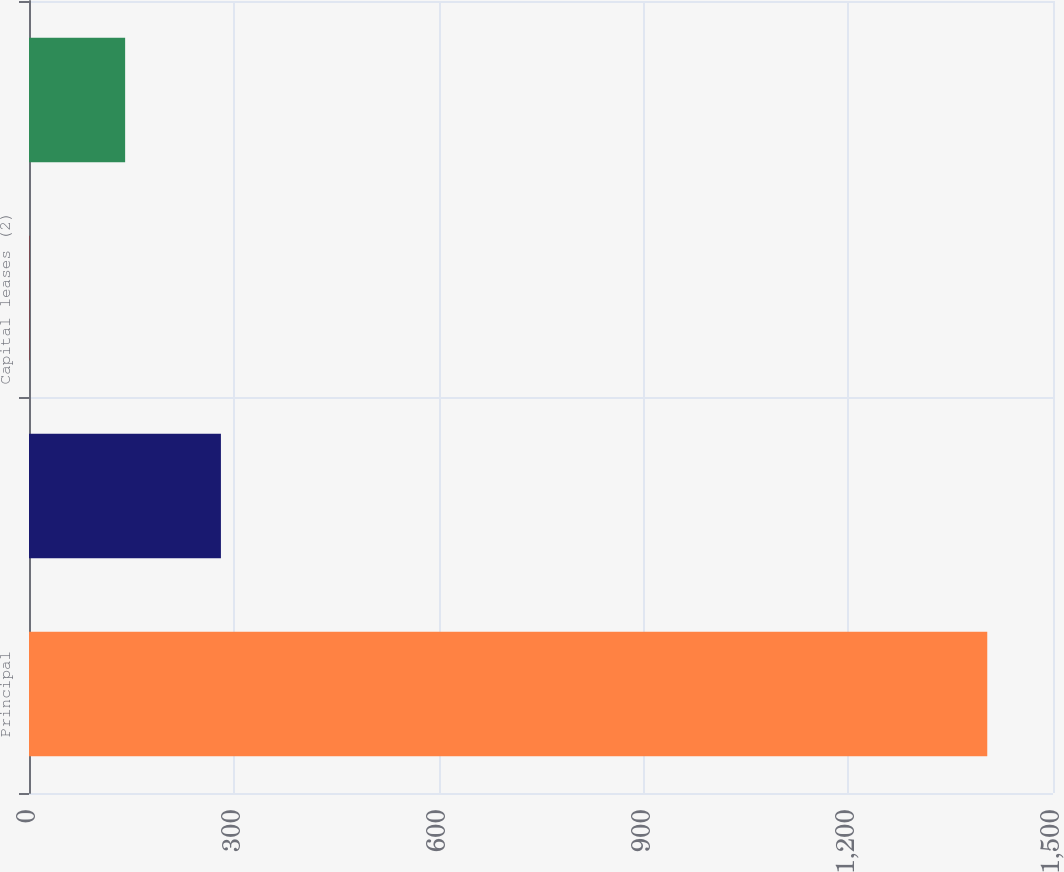<chart> <loc_0><loc_0><loc_500><loc_500><bar_chart><fcel>Principal<fcel>Interest (3)<fcel>Capital leases (2)<fcel>Operating leases (4)<nl><fcel>1403.7<fcel>281.14<fcel>0.5<fcel>140.82<nl></chart> 